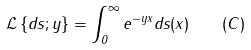Convert formula to latex. <formula><loc_0><loc_0><loc_500><loc_500>\mathcal { L } \left \{ d s ; y \right \} = \int ^ { \infty } _ { 0 } e ^ { - y x } d s ( x ) \quad ( C )</formula> 